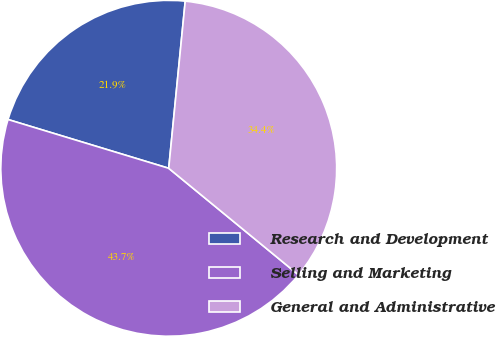Convert chart. <chart><loc_0><loc_0><loc_500><loc_500><pie_chart><fcel>Research and Development<fcel>Selling and Marketing<fcel>General and Administrative<nl><fcel>21.88%<fcel>43.75%<fcel>34.38%<nl></chart> 